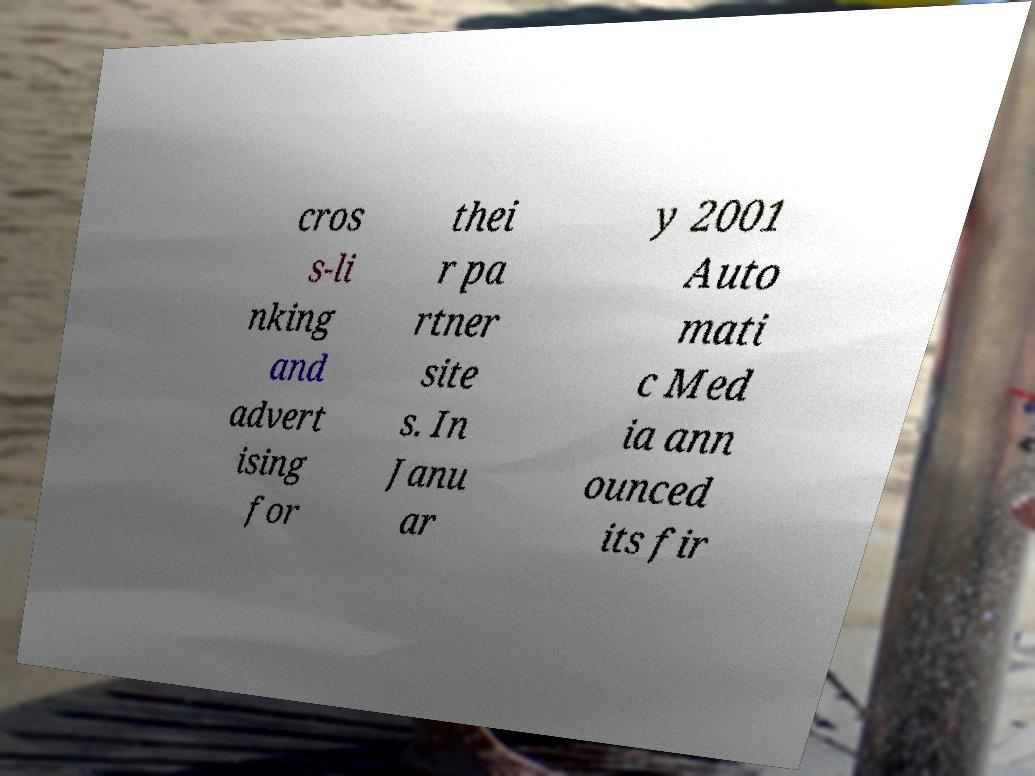What messages or text are displayed in this image? I need them in a readable, typed format. cros s-li nking and advert ising for thei r pa rtner site s. In Janu ar y 2001 Auto mati c Med ia ann ounced its fir 